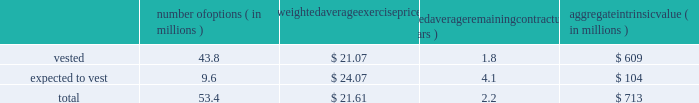Intel corporation notes to consolidated financial statements ( continued ) the aggregate fair value of awards that vested in 2015 was $ 1.5 billion ( $ 1.1 billion in 2014 and $ 1.0 billion in 2013 ) , which represents the market value of our common stock on the date that the rsus vested .
The grant-date fair value of awards that vested in 2015 was $ 1.1 billion ( $ 949 million in 2014 and $ 899 million in 2013 ) .
The number of rsus vested includes shares of common stock that we withheld on behalf of employees to satisfy the minimum statutory tax withholding requirements .
Rsus that are expected to vest are net of estimated future forfeitures .
As of december 26 , 2015 , there was $ 1.8 billion in unrecognized compensation costs related to rsus granted under our equity incentive plans .
We expect to recognize those costs over a weighted average period of 1.2 years .
Stock option awards as of december 26 , 2015 , options outstanding that have vested and are expected to vest were as follows : number of options ( in millions ) weighted average exercise weighted average remaining contractual ( in years ) aggregate intrinsic ( in millions ) .
Aggregate intrinsic value represents the difference between the exercise price and $ 34.98 , the closing price of our common stock on december 24 , 2015 , as reported on the nasdaq global select market , for all in-the-money options outstanding .
Options outstanding that are expected to vest are net of estimated future option forfeitures .
Options with a fair value of $ 42 million completed vesting in 2015 ( $ 68 million in 2014 and $ 186 million in 2013 ) .
As of december 26 , 2015 , there was $ 13 million in unrecognized compensation costs related to stock options granted under our equity incentive plans .
We expect to recognize those costs over a weighted average period of approximately eight months. .
As of december 26 , 2015 , what was the expected unrecognized compensation costs to be recognized per year in billions? 
Rationale: as of december 26 , 2015 , the company expected 1.5 billion of unrecognized compensation costs to be recognized per year
Computations: (1.8 / 1.2)
Answer: 1.5. 